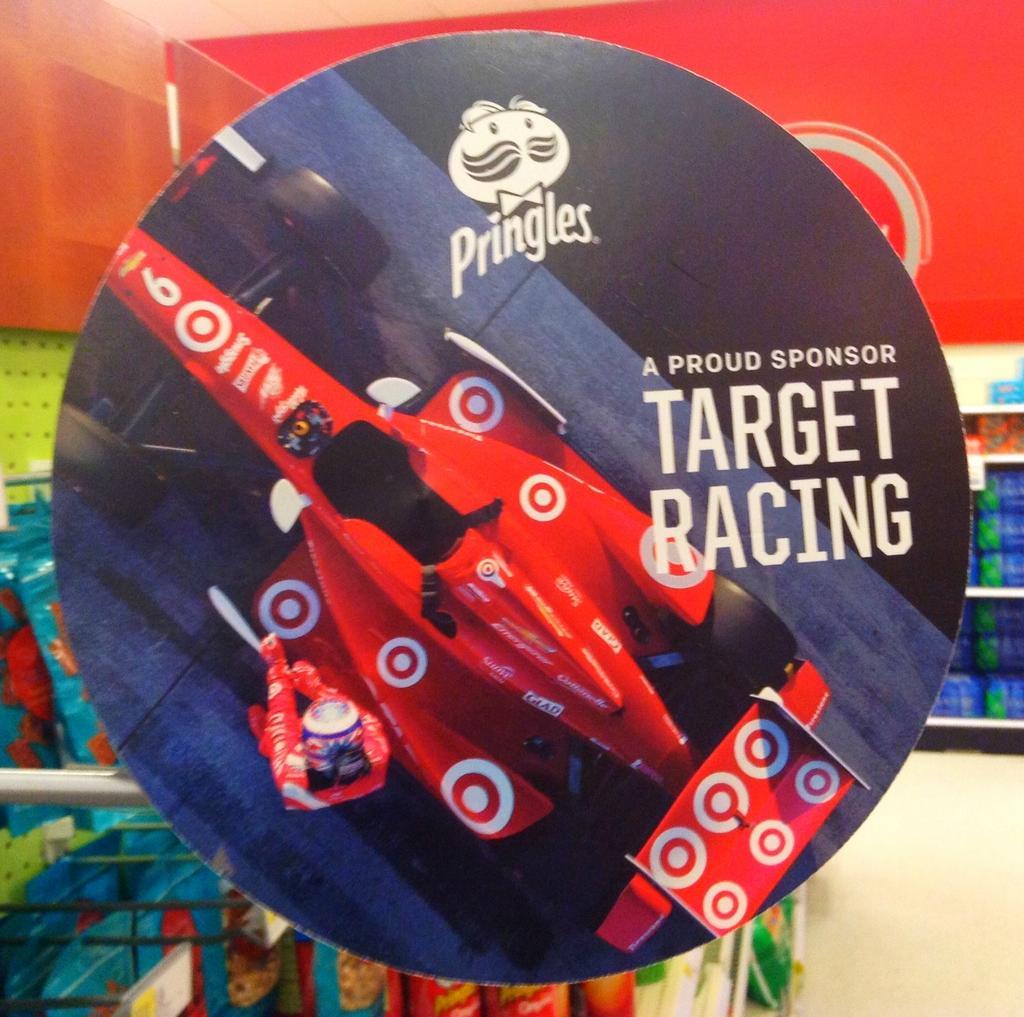Describe this image in one or two sentences. In this picture we can see a board. In the background there are racks. 